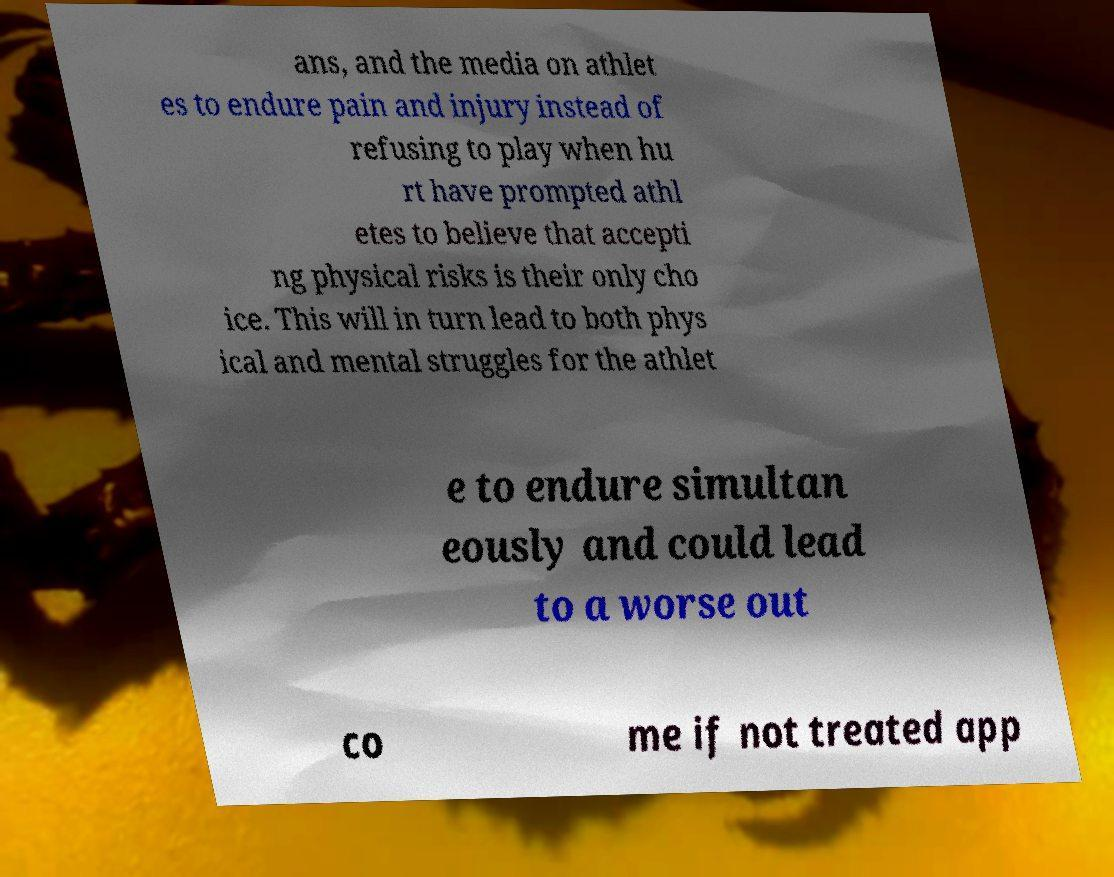Please identify and transcribe the text found in this image. ans, and the media on athlet es to endure pain and injury instead of refusing to play when hu rt have prompted athl etes to believe that accepti ng physical risks is their only cho ice. This will in turn lead to both phys ical and mental struggles for the athlet e to endure simultan eously and could lead to a worse out co me if not treated app 